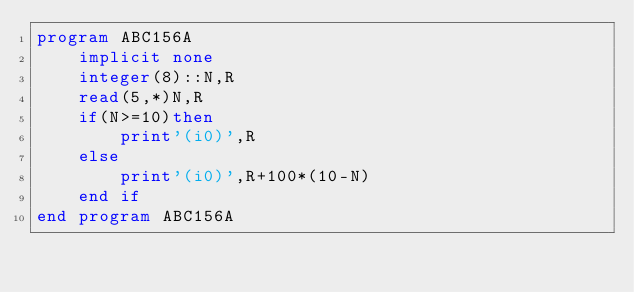Convert code to text. <code><loc_0><loc_0><loc_500><loc_500><_FORTRAN_>program ABC156A
    implicit none
    integer(8)::N,R
    read(5,*)N,R
    if(N>=10)then
        print'(i0)',R
    else
        print'(i0)',R+100*(10-N)
    end if
end program ABC156A</code> 